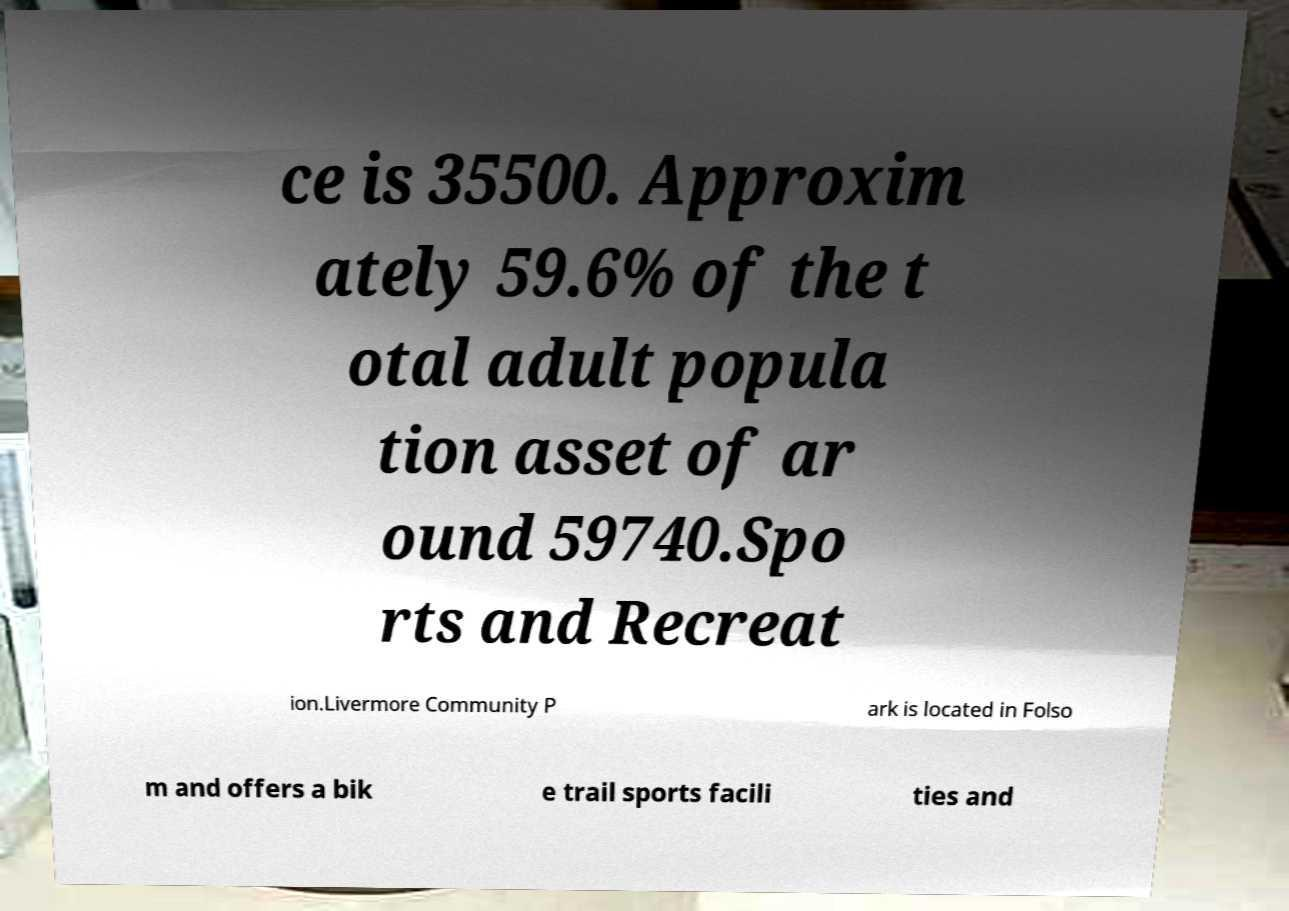Could you assist in decoding the text presented in this image and type it out clearly? ce is 35500. Approxim ately 59.6% of the t otal adult popula tion asset of ar ound 59740.Spo rts and Recreat ion.Livermore Community P ark is located in Folso m and offers a bik e trail sports facili ties and 